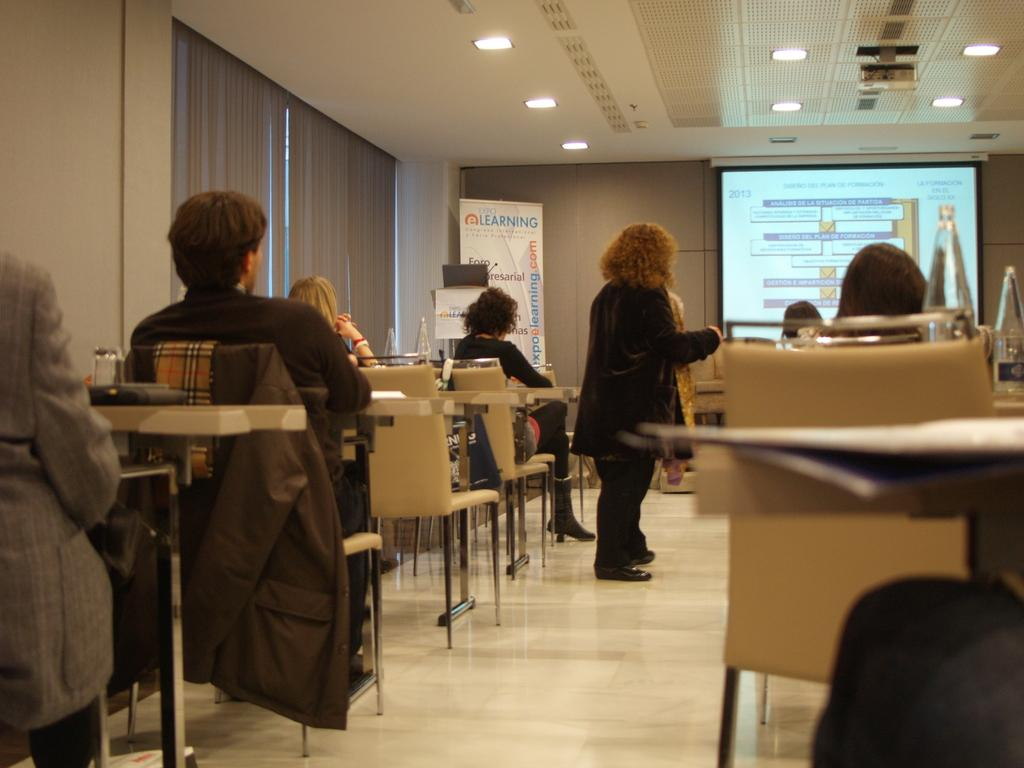What is the main subject of the image? The main subject of the image is a group of people. What are the people in the image doing? The people are seated on chairs. What additional feature can be seen in the image? There is a projector screen in the image. Is there anyone standing in the image? Yes, there is a woman standing in the image. What type of fowl can be seen flying over the group of people in the image? There is no fowl visible in the image; it only features a group of people seated on chairs, a woman standing, and a projector screen. 